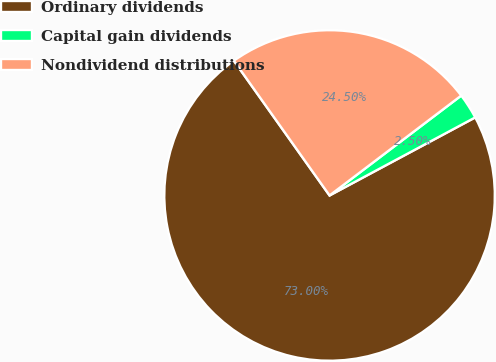<chart> <loc_0><loc_0><loc_500><loc_500><pie_chart><fcel>Ordinary dividends<fcel>Capital gain dividends<fcel>Nondividend distributions<nl><fcel>73.0%<fcel>2.5%<fcel>24.5%<nl></chart> 